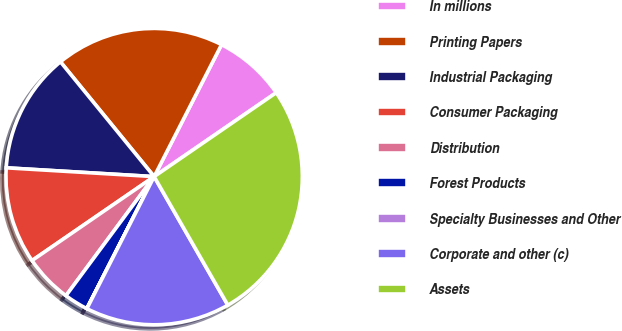Convert chart to OTSL. <chart><loc_0><loc_0><loc_500><loc_500><pie_chart><fcel>In millions<fcel>Printing Papers<fcel>Industrial Packaging<fcel>Consumer Packaging<fcel>Distribution<fcel>Forest Products<fcel>Specialty Businesses and Other<fcel>Corporate and other (c)<fcel>Assets<nl><fcel>7.9%<fcel>18.41%<fcel>13.16%<fcel>10.53%<fcel>5.27%<fcel>2.64%<fcel>0.01%<fcel>15.78%<fcel>26.3%<nl></chart> 